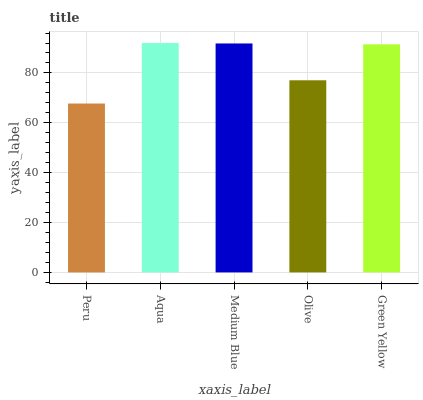Is Peru the minimum?
Answer yes or no. Yes. Is Aqua the maximum?
Answer yes or no. Yes. Is Medium Blue the minimum?
Answer yes or no. No. Is Medium Blue the maximum?
Answer yes or no. No. Is Aqua greater than Medium Blue?
Answer yes or no. Yes. Is Medium Blue less than Aqua?
Answer yes or no. Yes. Is Medium Blue greater than Aqua?
Answer yes or no. No. Is Aqua less than Medium Blue?
Answer yes or no. No. Is Green Yellow the high median?
Answer yes or no. Yes. Is Green Yellow the low median?
Answer yes or no. Yes. Is Olive the high median?
Answer yes or no. No. Is Aqua the low median?
Answer yes or no. No. 